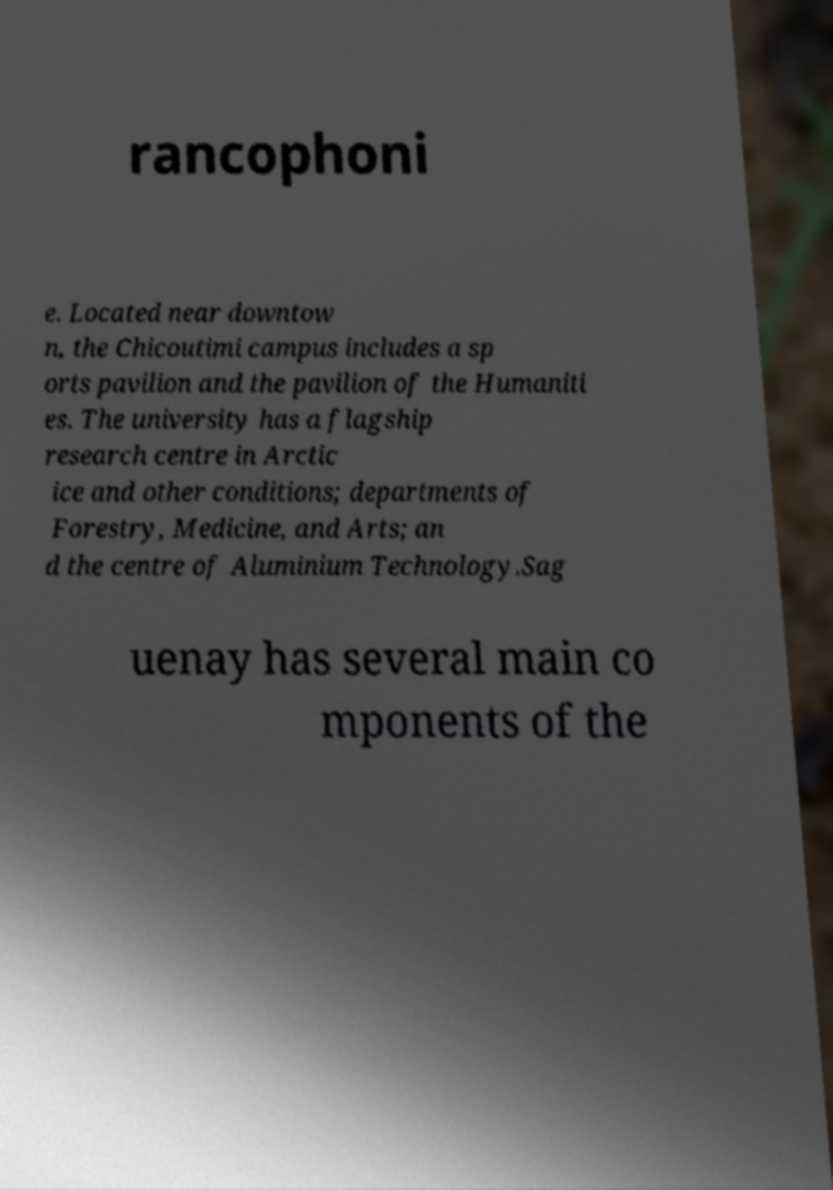Could you extract and type out the text from this image? rancophoni e. Located near downtow n, the Chicoutimi campus includes a sp orts pavilion and the pavilion of the Humaniti es. The university has a flagship research centre in Arctic ice and other conditions; departments of Forestry, Medicine, and Arts; an d the centre of Aluminium Technology.Sag uenay has several main co mponents of the 